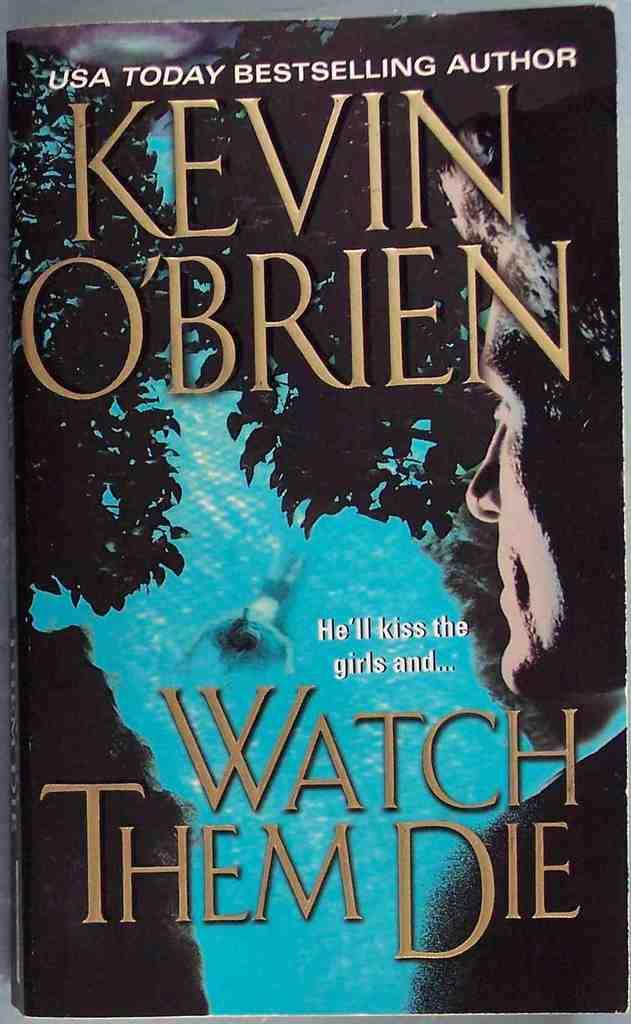<image>
Write a terse but informative summary of the picture. A book that says Watch Them Die on it 